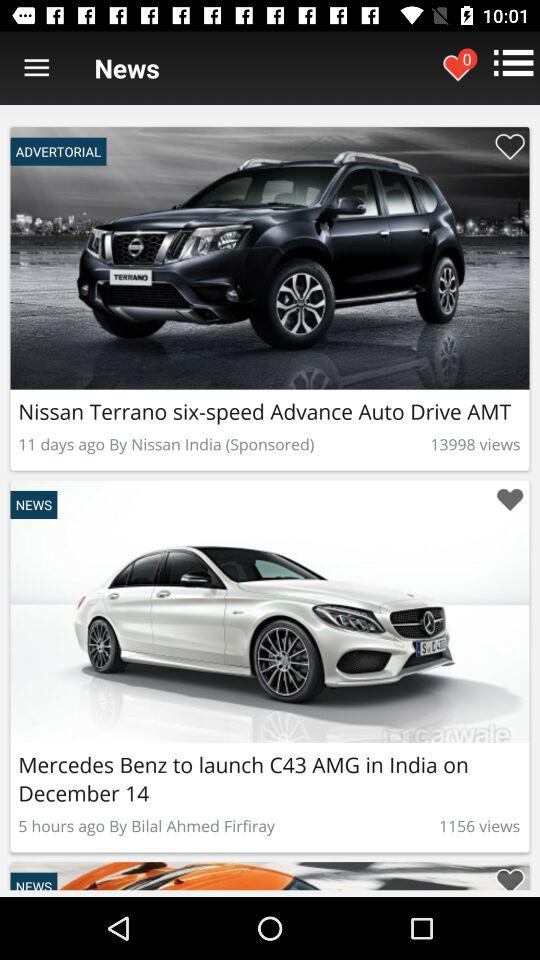When was the article "Mercedes Benz to launch C43 in India" published? The article was published 5 hours ago. 